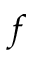<formula> <loc_0><loc_0><loc_500><loc_500>f</formula> 